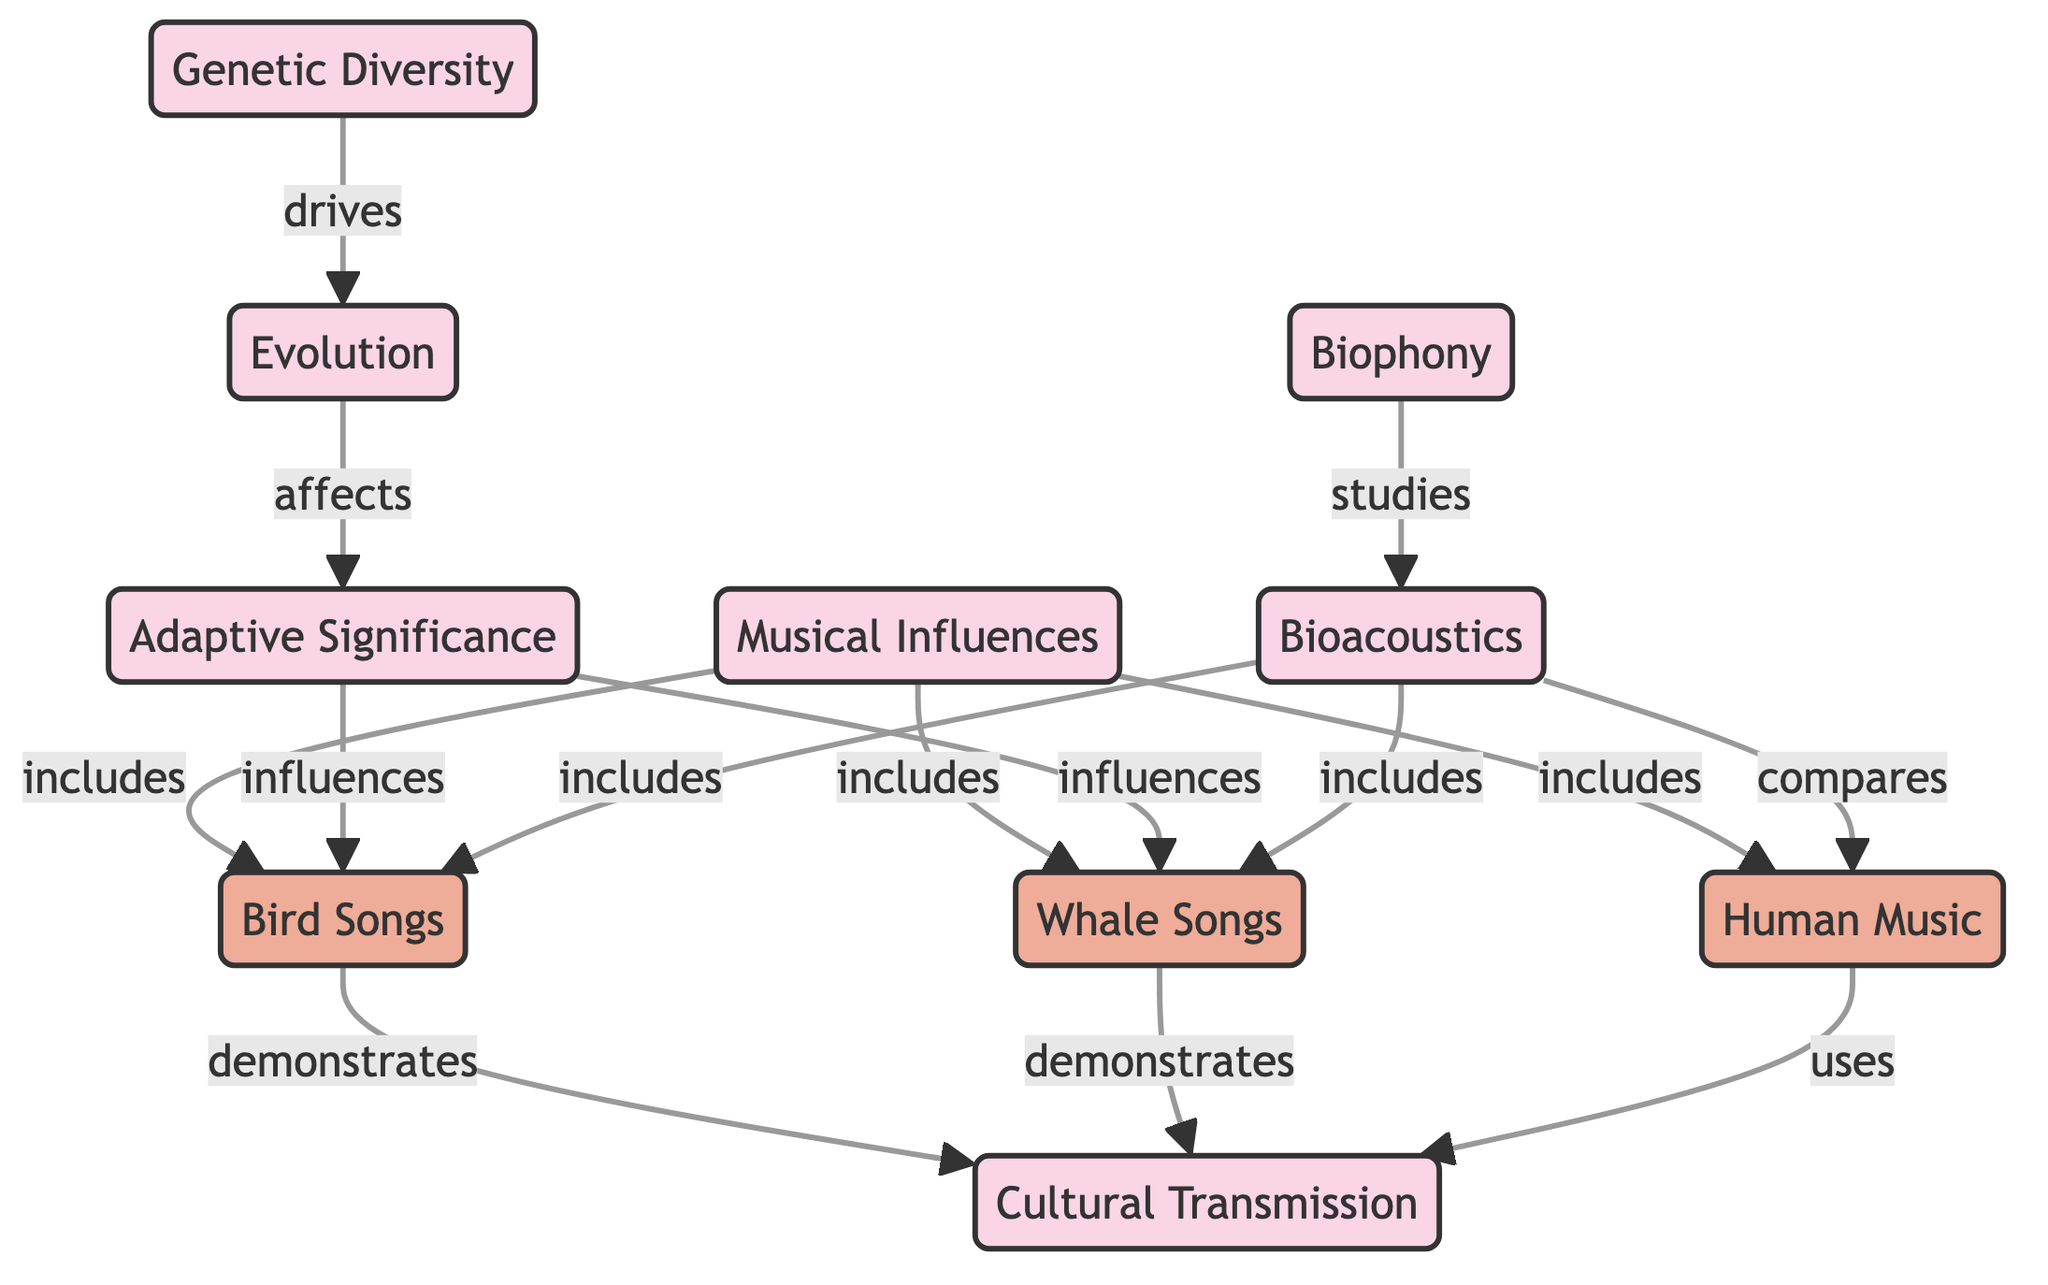What is the relationship between genetic diversity and evolution? The diagram states that genetic diversity "drives" evolution, indicating that genetic diversity is a motivating factor for evolutionary changes.
Answer: drives How many species are listed under musical influences? There are three species listed: Bird Songs, Whale Songs, and Human Music. Thus, the count is based on the connections from the musical influences node to these three species.
Answer: 3 What does cultural transmission demonstrate in relation to bird songs? The diagram indicates that bird songs "demonstrate" cultural transmission, which means that bird songs exemplify how cultural practices are transferred.
Answer: demonstrates Which concept is influenced by adaptive significance? The adaptive significance concept influences both bird songs and whale songs, as indicated by the connections from adaptive significance to these species in the diagram.
Answer: bird songs, whale songs How does bioacoustics relate to biophony in this diagram? The diagram shows that biophony "studies" bioacoustics, suggesting that biophony focuses on understanding the soundscapes produced by different organisms through bioacoustics.
Answer: studies What node shows the connection between species and cultural transmission? The connections show that bird songs and whale songs "demonstrate" cultural transmission, while human music "uses" it, linking these species directly to the cultural transmission concept.
Answer: cultural transmission What type of musical influences includes the species human music? Human music is included as an example under the broader category of musical influences, as shown by the connection from musical influences to human music in the diagram.
Answer: musical influences How many relationships connect evolution to other concepts? The diagram shows two relationships stemming from evolution: it drives genetic diversity and affects adaptive significance. This gives a total of two relationships connected to evolution.
Answer: 2 What examples are included under bioacoustics? Bioacoustics includes bird songs and whale songs, as indicated by the outgoing connections from bioacoustics to these species in the diagram.
Answer: bird songs, whale songs 